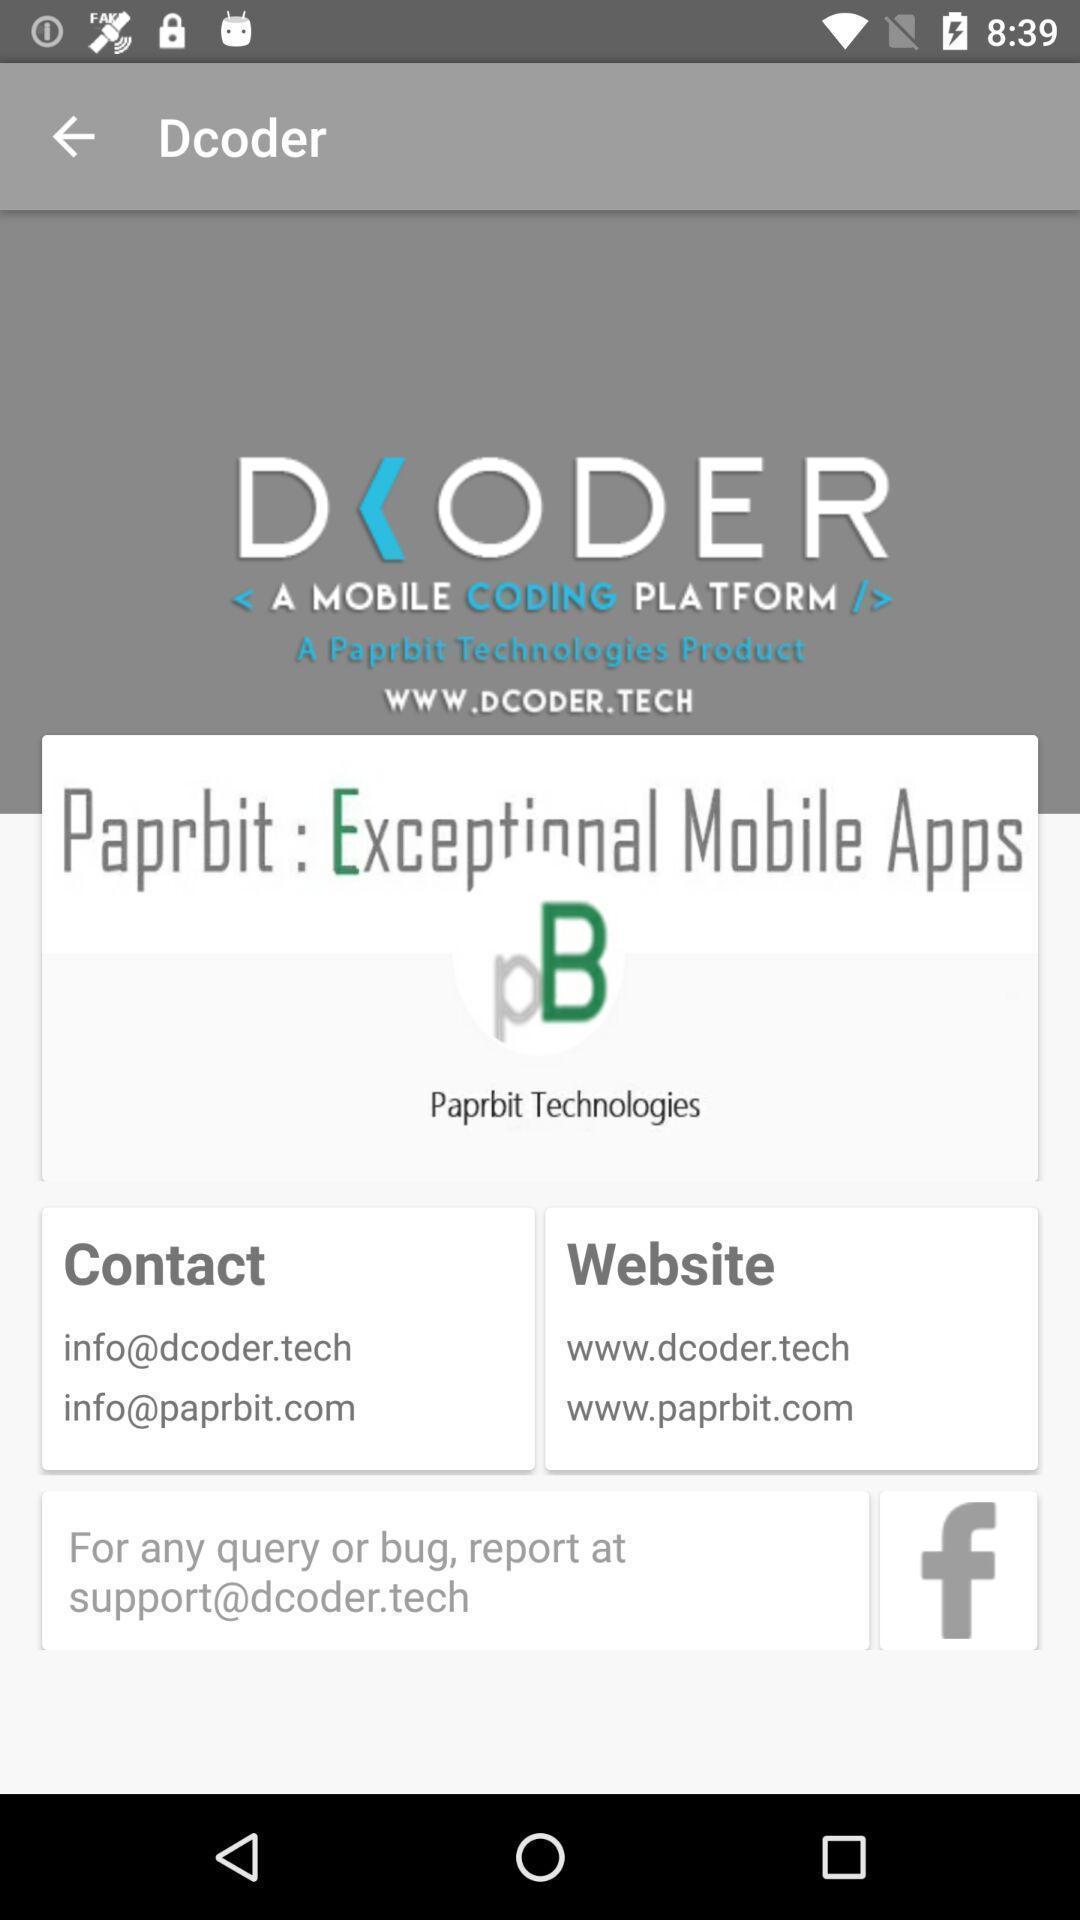What details can you identify in this image? Welcome page. 